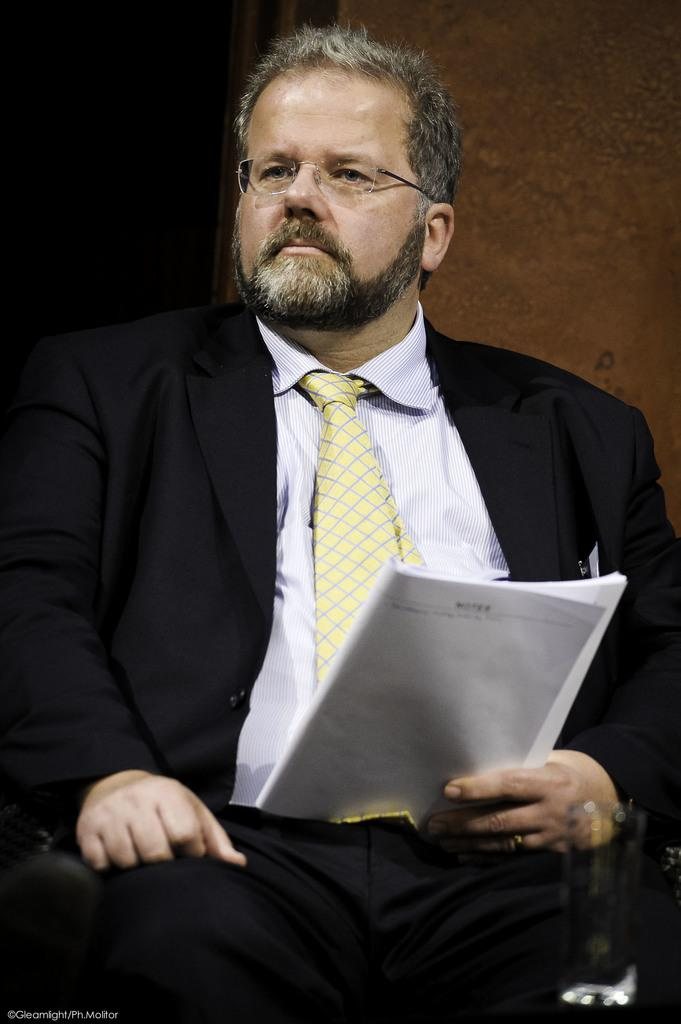What is the main subject of the image? The main subject of the image is a man. What is the man wearing in the image? The man is wearing a blazer, a tie, and spectacles in the image. What is the man holding in the image? The man is holding a paper in his hand in the image. What can be seen in the background of the image? There is a wall in the background of the image. How many buttons can be seen on the man's blazer in the image? There is no information about buttons on the man's blazer in the provided facts, so we cannot determine the number of buttons. Is there a bat visible in the image? There is no mention of a bat in the provided facts, so we cannot determine if a bat is present in the image. 